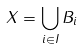<formula> <loc_0><loc_0><loc_500><loc_500>X = \bigcup _ { i \in I } B _ { i }</formula> 